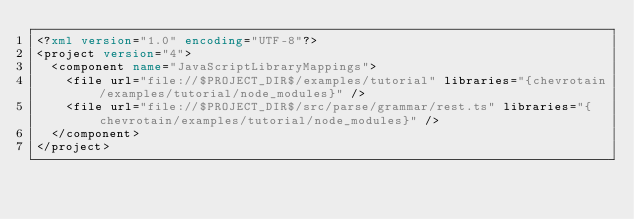Convert code to text. <code><loc_0><loc_0><loc_500><loc_500><_XML_><?xml version="1.0" encoding="UTF-8"?>
<project version="4">
  <component name="JavaScriptLibraryMappings">
    <file url="file://$PROJECT_DIR$/examples/tutorial" libraries="{chevrotain/examples/tutorial/node_modules}" />
    <file url="file://$PROJECT_DIR$/src/parse/grammar/rest.ts" libraries="{chevrotain/examples/tutorial/node_modules}" />
  </component>
</project></code> 